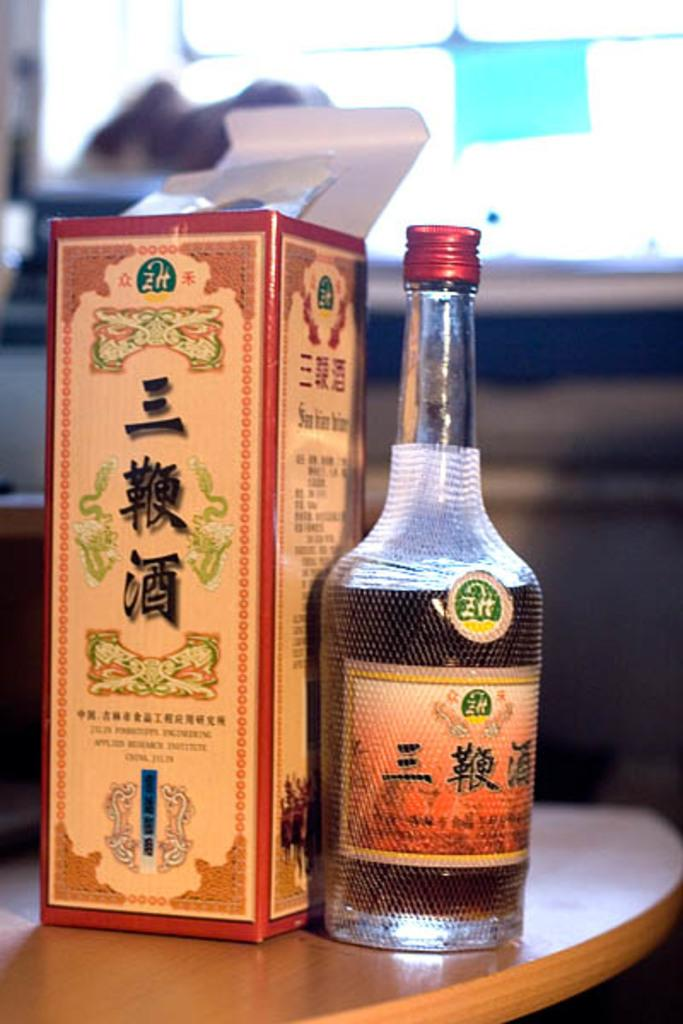<image>
Provide a brief description of the given image. Lots of foreign words are written on thsi bottle and box. 